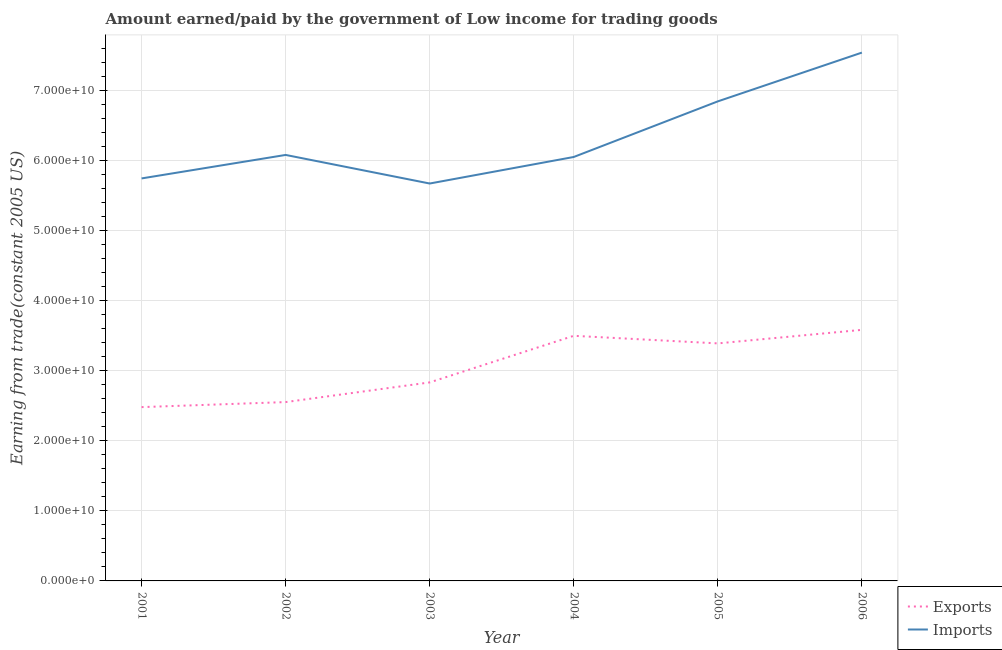How many different coloured lines are there?
Offer a terse response. 2. What is the amount earned from exports in 2004?
Your answer should be very brief. 3.50e+1. Across all years, what is the maximum amount earned from exports?
Offer a terse response. 3.58e+1. Across all years, what is the minimum amount paid for imports?
Keep it short and to the point. 5.67e+1. In which year was the amount earned from exports minimum?
Offer a terse response. 2001. What is the total amount earned from exports in the graph?
Ensure brevity in your answer.  1.83e+11. What is the difference between the amount paid for imports in 2002 and that in 2003?
Keep it short and to the point. 4.08e+09. What is the difference between the amount earned from exports in 2003 and the amount paid for imports in 2006?
Give a very brief answer. -4.70e+1. What is the average amount paid for imports per year?
Offer a very short reply. 6.32e+1. In the year 2003, what is the difference between the amount earned from exports and amount paid for imports?
Provide a succinct answer. -2.84e+1. In how many years, is the amount paid for imports greater than 46000000000 US$?
Keep it short and to the point. 6. What is the ratio of the amount paid for imports in 2002 to that in 2006?
Make the answer very short. 0.81. Is the amount earned from exports in 2001 less than that in 2002?
Offer a terse response. Yes. Is the difference between the amount earned from exports in 2002 and 2004 greater than the difference between the amount paid for imports in 2002 and 2004?
Your response must be concise. No. What is the difference between the highest and the second highest amount earned from exports?
Ensure brevity in your answer.  8.49e+08. What is the difference between the highest and the lowest amount earned from exports?
Make the answer very short. 1.10e+1. In how many years, is the amount earned from exports greater than the average amount earned from exports taken over all years?
Your answer should be compact. 3. Does the amount paid for imports monotonically increase over the years?
Provide a short and direct response. No. Is the amount earned from exports strictly greater than the amount paid for imports over the years?
Keep it short and to the point. No. Is the amount paid for imports strictly less than the amount earned from exports over the years?
Make the answer very short. No. How many lines are there?
Provide a short and direct response. 2. How many years are there in the graph?
Provide a succinct answer. 6. What is the difference between two consecutive major ticks on the Y-axis?
Your answer should be very brief. 1.00e+1. Are the values on the major ticks of Y-axis written in scientific E-notation?
Your response must be concise. Yes. Does the graph contain grids?
Give a very brief answer. Yes. What is the title of the graph?
Keep it short and to the point. Amount earned/paid by the government of Low income for trading goods. Does "Export" appear as one of the legend labels in the graph?
Offer a terse response. No. What is the label or title of the X-axis?
Make the answer very short. Year. What is the label or title of the Y-axis?
Keep it short and to the point. Earning from trade(constant 2005 US). What is the Earning from trade(constant 2005 US) in Exports in 2001?
Your response must be concise. 2.48e+1. What is the Earning from trade(constant 2005 US) in Imports in 2001?
Make the answer very short. 5.74e+1. What is the Earning from trade(constant 2005 US) of Exports in 2002?
Give a very brief answer. 2.55e+1. What is the Earning from trade(constant 2005 US) in Imports in 2002?
Your answer should be compact. 6.08e+1. What is the Earning from trade(constant 2005 US) in Exports in 2003?
Offer a terse response. 2.83e+1. What is the Earning from trade(constant 2005 US) of Imports in 2003?
Make the answer very short. 5.67e+1. What is the Earning from trade(constant 2005 US) of Exports in 2004?
Your response must be concise. 3.50e+1. What is the Earning from trade(constant 2005 US) of Imports in 2004?
Your response must be concise. 6.05e+1. What is the Earning from trade(constant 2005 US) of Exports in 2005?
Provide a succinct answer. 3.39e+1. What is the Earning from trade(constant 2005 US) in Imports in 2005?
Your answer should be very brief. 6.84e+1. What is the Earning from trade(constant 2005 US) in Exports in 2006?
Your answer should be compact. 3.58e+1. What is the Earning from trade(constant 2005 US) of Imports in 2006?
Make the answer very short. 7.54e+1. Across all years, what is the maximum Earning from trade(constant 2005 US) of Exports?
Make the answer very short. 3.58e+1. Across all years, what is the maximum Earning from trade(constant 2005 US) of Imports?
Your response must be concise. 7.54e+1. Across all years, what is the minimum Earning from trade(constant 2005 US) in Exports?
Make the answer very short. 2.48e+1. Across all years, what is the minimum Earning from trade(constant 2005 US) of Imports?
Provide a short and direct response. 5.67e+1. What is the total Earning from trade(constant 2005 US) in Exports in the graph?
Provide a short and direct response. 1.83e+11. What is the total Earning from trade(constant 2005 US) in Imports in the graph?
Offer a terse response. 3.79e+11. What is the difference between the Earning from trade(constant 2005 US) of Exports in 2001 and that in 2002?
Your answer should be compact. -7.19e+08. What is the difference between the Earning from trade(constant 2005 US) of Imports in 2001 and that in 2002?
Your answer should be very brief. -3.35e+09. What is the difference between the Earning from trade(constant 2005 US) of Exports in 2001 and that in 2003?
Provide a succinct answer. -3.52e+09. What is the difference between the Earning from trade(constant 2005 US) in Imports in 2001 and that in 2003?
Provide a short and direct response. 7.26e+08. What is the difference between the Earning from trade(constant 2005 US) of Exports in 2001 and that in 2004?
Ensure brevity in your answer.  -1.02e+1. What is the difference between the Earning from trade(constant 2005 US) in Imports in 2001 and that in 2004?
Make the answer very short. -3.06e+09. What is the difference between the Earning from trade(constant 2005 US) of Exports in 2001 and that in 2005?
Your response must be concise. -9.09e+09. What is the difference between the Earning from trade(constant 2005 US) in Imports in 2001 and that in 2005?
Offer a terse response. -1.10e+1. What is the difference between the Earning from trade(constant 2005 US) in Exports in 2001 and that in 2006?
Your response must be concise. -1.10e+1. What is the difference between the Earning from trade(constant 2005 US) of Imports in 2001 and that in 2006?
Keep it short and to the point. -1.79e+1. What is the difference between the Earning from trade(constant 2005 US) of Exports in 2002 and that in 2003?
Ensure brevity in your answer.  -2.81e+09. What is the difference between the Earning from trade(constant 2005 US) of Imports in 2002 and that in 2003?
Keep it short and to the point. 4.08e+09. What is the difference between the Earning from trade(constant 2005 US) in Exports in 2002 and that in 2004?
Offer a terse response. -9.45e+09. What is the difference between the Earning from trade(constant 2005 US) of Imports in 2002 and that in 2004?
Your response must be concise. 2.92e+08. What is the difference between the Earning from trade(constant 2005 US) in Exports in 2002 and that in 2005?
Offer a terse response. -8.37e+09. What is the difference between the Earning from trade(constant 2005 US) in Imports in 2002 and that in 2005?
Offer a terse response. -7.64e+09. What is the difference between the Earning from trade(constant 2005 US) of Exports in 2002 and that in 2006?
Your response must be concise. -1.03e+1. What is the difference between the Earning from trade(constant 2005 US) of Imports in 2002 and that in 2006?
Your answer should be compact. -1.46e+1. What is the difference between the Earning from trade(constant 2005 US) in Exports in 2003 and that in 2004?
Provide a short and direct response. -6.65e+09. What is the difference between the Earning from trade(constant 2005 US) in Imports in 2003 and that in 2004?
Provide a succinct answer. -3.79e+09. What is the difference between the Earning from trade(constant 2005 US) of Exports in 2003 and that in 2005?
Keep it short and to the point. -5.56e+09. What is the difference between the Earning from trade(constant 2005 US) of Imports in 2003 and that in 2005?
Provide a short and direct response. -1.17e+1. What is the difference between the Earning from trade(constant 2005 US) of Exports in 2003 and that in 2006?
Provide a succinct answer. -7.50e+09. What is the difference between the Earning from trade(constant 2005 US) in Imports in 2003 and that in 2006?
Your response must be concise. -1.87e+1. What is the difference between the Earning from trade(constant 2005 US) of Exports in 2004 and that in 2005?
Make the answer very short. 1.08e+09. What is the difference between the Earning from trade(constant 2005 US) of Imports in 2004 and that in 2005?
Your response must be concise. -7.93e+09. What is the difference between the Earning from trade(constant 2005 US) in Exports in 2004 and that in 2006?
Provide a short and direct response. -8.49e+08. What is the difference between the Earning from trade(constant 2005 US) of Imports in 2004 and that in 2006?
Ensure brevity in your answer.  -1.49e+1. What is the difference between the Earning from trade(constant 2005 US) in Exports in 2005 and that in 2006?
Provide a short and direct response. -1.93e+09. What is the difference between the Earning from trade(constant 2005 US) in Imports in 2005 and that in 2006?
Make the answer very short. -6.96e+09. What is the difference between the Earning from trade(constant 2005 US) of Exports in 2001 and the Earning from trade(constant 2005 US) of Imports in 2002?
Your answer should be compact. -3.60e+1. What is the difference between the Earning from trade(constant 2005 US) of Exports in 2001 and the Earning from trade(constant 2005 US) of Imports in 2003?
Ensure brevity in your answer.  -3.19e+1. What is the difference between the Earning from trade(constant 2005 US) in Exports in 2001 and the Earning from trade(constant 2005 US) in Imports in 2004?
Offer a terse response. -3.57e+1. What is the difference between the Earning from trade(constant 2005 US) in Exports in 2001 and the Earning from trade(constant 2005 US) in Imports in 2005?
Keep it short and to the point. -4.36e+1. What is the difference between the Earning from trade(constant 2005 US) in Exports in 2001 and the Earning from trade(constant 2005 US) in Imports in 2006?
Ensure brevity in your answer.  -5.06e+1. What is the difference between the Earning from trade(constant 2005 US) in Exports in 2002 and the Earning from trade(constant 2005 US) in Imports in 2003?
Provide a short and direct response. -3.12e+1. What is the difference between the Earning from trade(constant 2005 US) of Exports in 2002 and the Earning from trade(constant 2005 US) of Imports in 2004?
Keep it short and to the point. -3.50e+1. What is the difference between the Earning from trade(constant 2005 US) in Exports in 2002 and the Earning from trade(constant 2005 US) in Imports in 2005?
Keep it short and to the point. -4.29e+1. What is the difference between the Earning from trade(constant 2005 US) of Exports in 2002 and the Earning from trade(constant 2005 US) of Imports in 2006?
Give a very brief answer. -4.98e+1. What is the difference between the Earning from trade(constant 2005 US) in Exports in 2003 and the Earning from trade(constant 2005 US) in Imports in 2004?
Keep it short and to the point. -3.22e+1. What is the difference between the Earning from trade(constant 2005 US) of Exports in 2003 and the Earning from trade(constant 2005 US) of Imports in 2005?
Give a very brief answer. -4.01e+1. What is the difference between the Earning from trade(constant 2005 US) in Exports in 2003 and the Earning from trade(constant 2005 US) in Imports in 2006?
Provide a short and direct response. -4.70e+1. What is the difference between the Earning from trade(constant 2005 US) of Exports in 2004 and the Earning from trade(constant 2005 US) of Imports in 2005?
Ensure brevity in your answer.  -3.34e+1. What is the difference between the Earning from trade(constant 2005 US) of Exports in 2004 and the Earning from trade(constant 2005 US) of Imports in 2006?
Provide a short and direct response. -4.04e+1. What is the difference between the Earning from trade(constant 2005 US) in Exports in 2005 and the Earning from trade(constant 2005 US) in Imports in 2006?
Offer a very short reply. -4.15e+1. What is the average Earning from trade(constant 2005 US) of Exports per year?
Give a very brief answer. 3.05e+1. What is the average Earning from trade(constant 2005 US) of Imports per year?
Offer a terse response. 6.32e+1. In the year 2001, what is the difference between the Earning from trade(constant 2005 US) of Exports and Earning from trade(constant 2005 US) of Imports?
Offer a very short reply. -3.26e+1. In the year 2002, what is the difference between the Earning from trade(constant 2005 US) in Exports and Earning from trade(constant 2005 US) in Imports?
Your answer should be compact. -3.53e+1. In the year 2003, what is the difference between the Earning from trade(constant 2005 US) in Exports and Earning from trade(constant 2005 US) in Imports?
Provide a short and direct response. -2.84e+1. In the year 2004, what is the difference between the Earning from trade(constant 2005 US) in Exports and Earning from trade(constant 2005 US) in Imports?
Provide a short and direct response. -2.55e+1. In the year 2005, what is the difference between the Earning from trade(constant 2005 US) of Exports and Earning from trade(constant 2005 US) of Imports?
Offer a very short reply. -3.45e+1. In the year 2006, what is the difference between the Earning from trade(constant 2005 US) in Exports and Earning from trade(constant 2005 US) in Imports?
Provide a succinct answer. -3.95e+1. What is the ratio of the Earning from trade(constant 2005 US) of Exports in 2001 to that in 2002?
Offer a terse response. 0.97. What is the ratio of the Earning from trade(constant 2005 US) in Imports in 2001 to that in 2002?
Provide a short and direct response. 0.94. What is the ratio of the Earning from trade(constant 2005 US) of Exports in 2001 to that in 2003?
Keep it short and to the point. 0.88. What is the ratio of the Earning from trade(constant 2005 US) in Imports in 2001 to that in 2003?
Your answer should be compact. 1.01. What is the ratio of the Earning from trade(constant 2005 US) in Exports in 2001 to that in 2004?
Your answer should be compact. 0.71. What is the ratio of the Earning from trade(constant 2005 US) of Imports in 2001 to that in 2004?
Offer a terse response. 0.95. What is the ratio of the Earning from trade(constant 2005 US) of Exports in 2001 to that in 2005?
Ensure brevity in your answer.  0.73. What is the ratio of the Earning from trade(constant 2005 US) of Imports in 2001 to that in 2005?
Keep it short and to the point. 0.84. What is the ratio of the Earning from trade(constant 2005 US) of Exports in 2001 to that in 2006?
Your answer should be very brief. 0.69. What is the ratio of the Earning from trade(constant 2005 US) in Imports in 2001 to that in 2006?
Give a very brief answer. 0.76. What is the ratio of the Earning from trade(constant 2005 US) of Exports in 2002 to that in 2003?
Provide a short and direct response. 0.9. What is the ratio of the Earning from trade(constant 2005 US) of Imports in 2002 to that in 2003?
Ensure brevity in your answer.  1.07. What is the ratio of the Earning from trade(constant 2005 US) in Exports in 2002 to that in 2004?
Provide a succinct answer. 0.73. What is the ratio of the Earning from trade(constant 2005 US) of Imports in 2002 to that in 2004?
Provide a short and direct response. 1. What is the ratio of the Earning from trade(constant 2005 US) of Exports in 2002 to that in 2005?
Make the answer very short. 0.75. What is the ratio of the Earning from trade(constant 2005 US) in Imports in 2002 to that in 2005?
Your response must be concise. 0.89. What is the ratio of the Earning from trade(constant 2005 US) of Exports in 2002 to that in 2006?
Your answer should be very brief. 0.71. What is the ratio of the Earning from trade(constant 2005 US) of Imports in 2002 to that in 2006?
Your response must be concise. 0.81. What is the ratio of the Earning from trade(constant 2005 US) of Exports in 2003 to that in 2004?
Keep it short and to the point. 0.81. What is the ratio of the Earning from trade(constant 2005 US) of Imports in 2003 to that in 2004?
Provide a succinct answer. 0.94. What is the ratio of the Earning from trade(constant 2005 US) in Exports in 2003 to that in 2005?
Give a very brief answer. 0.84. What is the ratio of the Earning from trade(constant 2005 US) of Imports in 2003 to that in 2005?
Offer a very short reply. 0.83. What is the ratio of the Earning from trade(constant 2005 US) in Exports in 2003 to that in 2006?
Your response must be concise. 0.79. What is the ratio of the Earning from trade(constant 2005 US) of Imports in 2003 to that in 2006?
Your answer should be compact. 0.75. What is the ratio of the Earning from trade(constant 2005 US) in Exports in 2004 to that in 2005?
Ensure brevity in your answer.  1.03. What is the ratio of the Earning from trade(constant 2005 US) in Imports in 2004 to that in 2005?
Keep it short and to the point. 0.88. What is the ratio of the Earning from trade(constant 2005 US) in Exports in 2004 to that in 2006?
Make the answer very short. 0.98. What is the ratio of the Earning from trade(constant 2005 US) in Imports in 2004 to that in 2006?
Your answer should be very brief. 0.8. What is the ratio of the Earning from trade(constant 2005 US) of Exports in 2005 to that in 2006?
Make the answer very short. 0.95. What is the ratio of the Earning from trade(constant 2005 US) of Imports in 2005 to that in 2006?
Your response must be concise. 0.91. What is the difference between the highest and the second highest Earning from trade(constant 2005 US) of Exports?
Make the answer very short. 8.49e+08. What is the difference between the highest and the second highest Earning from trade(constant 2005 US) of Imports?
Your answer should be very brief. 6.96e+09. What is the difference between the highest and the lowest Earning from trade(constant 2005 US) in Exports?
Your response must be concise. 1.10e+1. What is the difference between the highest and the lowest Earning from trade(constant 2005 US) of Imports?
Make the answer very short. 1.87e+1. 